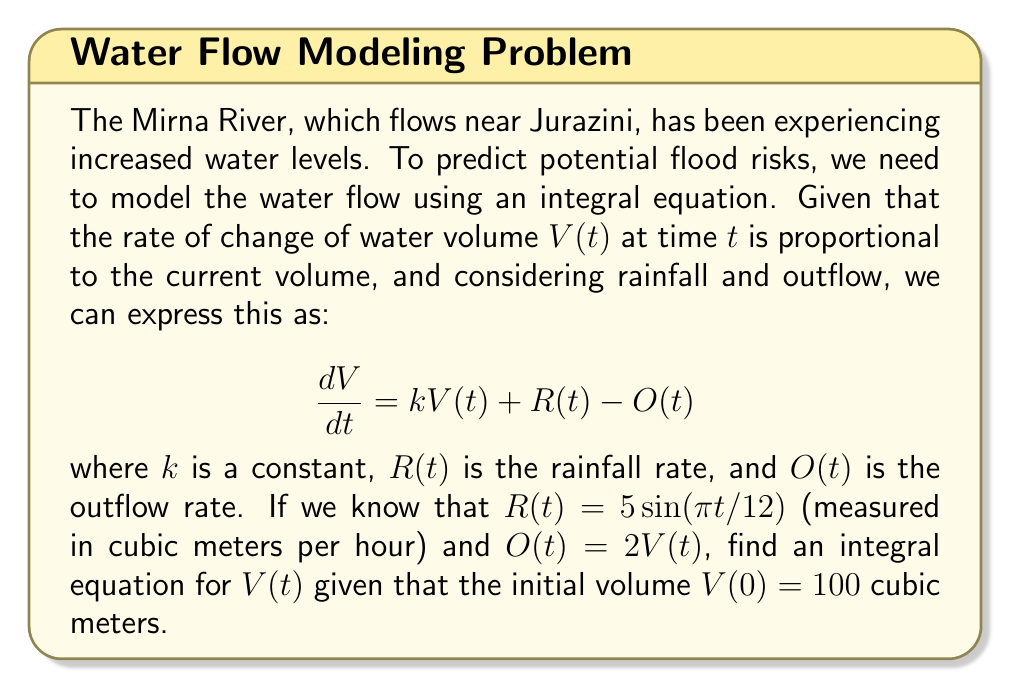Could you help me with this problem? Let's approach this step-by-step:

1) We start with the differential equation:
   $$\frac{dV}{dt} = kV(t) + R(t) - O(t)$$

2) Substitute the given functions for $R(t)$ and $O(t)$:
   $$\frac{dV}{dt} = kV(t) + 5\sin(\frac{πt}{12}) - 2V(t)$$

3) Simplify:
   $$\frac{dV}{dt} = (k-2)V(t) + 5\sin(\frac{πt}{12})$$

4) Let $a = k-2$ for simplicity:
   $$\frac{dV}{dt} = aV(t) + 5\sin(\frac{πt}{12})$$

5) To solve this, we use the integrating factor method. The integrating factor is $e^{-at}$:
   $$e^{-at}\frac{dV}{dt} - ae^{-at}V(t) = 5e^{-at}\sin(\frac{πt}{12})$$

6) The left side is now the derivative of $e^{-at}V(t)$:
   $$\frac{d}{dt}(e^{-at}V(t)) = 5e^{-at}\sin(\frac{πt}{12})$$

7) Integrate both sides:
   $$e^{-at}V(t) = 5\int e^{-at}\sin(\frac{πt}{12})dt + C$$

8) Solve for $V(t)$:
   $$V(t) = 5e^{at}\int e^{-at}\sin(\frac{πt}{12})dt + Ce^{at}$$

9) Use the initial condition $V(0) = 100$ to find $C$:
   $$100 = 0 + C$$
   $$C = 100$$

Therefore, the integral equation for $V(t)$ is:
$$V(t) = 5e^{at}\int e^{-at}\sin(\frac{πt}{12})dt + 100e^{at}$$
Answer: $$V(t) = 5e^{at}\int e^{-at}\sin(\frac{πt}{12})dt + 100e^{at}$$ 